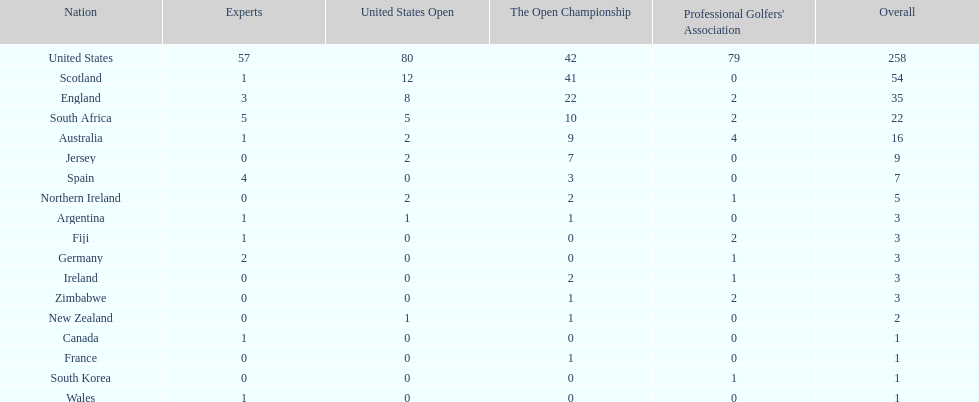How many countries have produced the same number of championship golfers as canada? 3. 